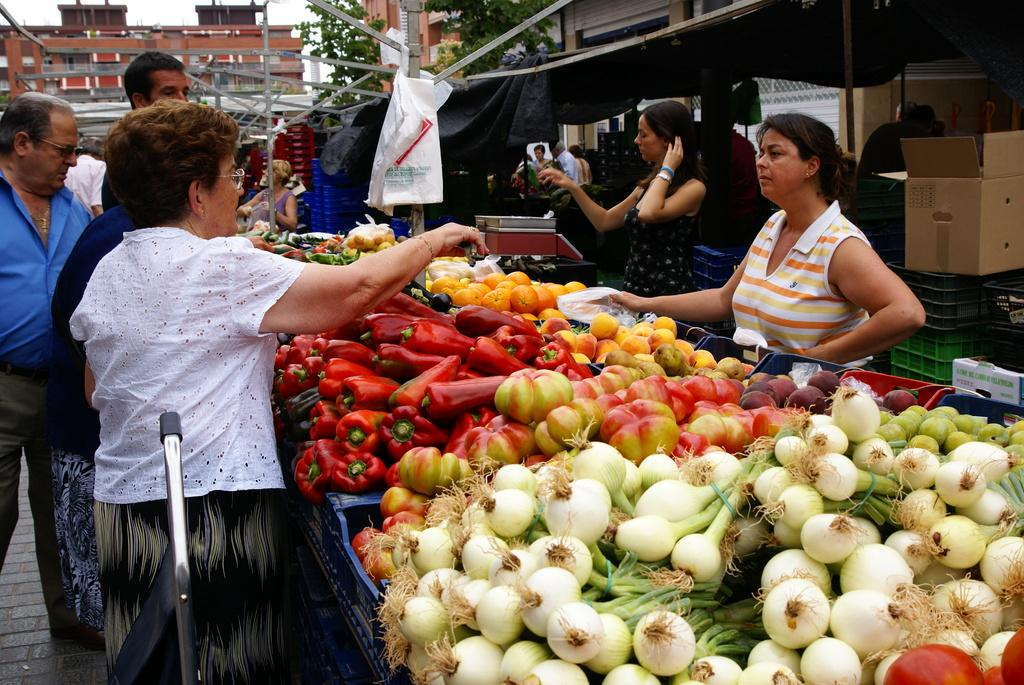What type of food is stored in the plastic containers in the image? There are vegetables in plastic containers in the image. What can be seen in the background of the image? There are buildings and trees visible in the image. What is the group of people standing doing? The context of the image is not clear, so their activity cannot be determined. What other objects are present in the image? There is a cardboard box and plastic containers in the image. What part of the natural environment is visible in the image? Trees and the sky are visible in the image. What type of poison is being used to teach the group of people standing in the image? There is no poison or teaching activity present in the image. What type of soap is being used to clean the vegetables in the image? There is no soap or cleaning activity involving the vegetables in the image. 